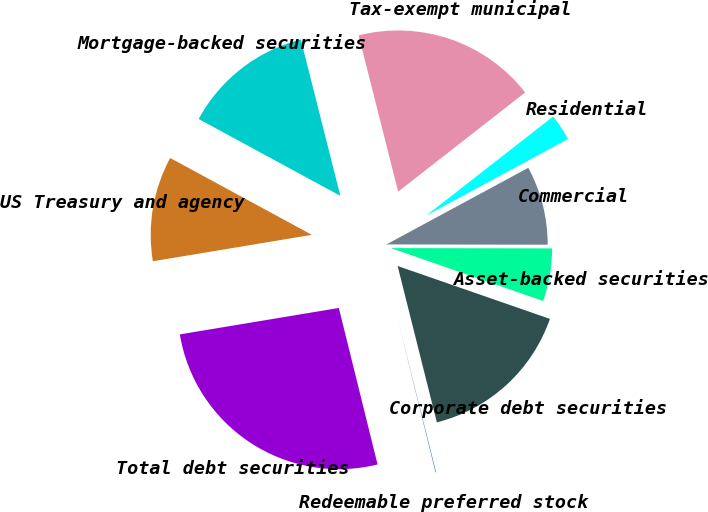Convert chart to OTSL. <chart><loc_0><loc_0><loc_500><loc_500><pie_chart><fcel>US Treasury and agency<fcel>Mortgage-backed securities<fcel>Tax-exempt municipal<fcel>Residential<fcel>Commercial<fcel>Asset-backed securities<fcel>Corporate debt securities<fcel>Redeemable preferred stock<fcel>Total debt securities<nl><fcel>10.53%<fcel>13.15%<fcel>18.39%<fcel>2.67%<fcel>7.91%<fcel>5.29%<fcel>15.77%<fcel>0.05%<fcel>26.24%<nl></chart> 